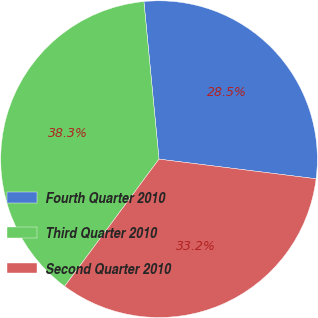Convert chart to OTSL. <chart><loc_0><loc_0><loc_500><loc_500><pie_chart><fcel>Fourth Quarter 2010<fcel>Third Quarter 2010<fcel>Second Quarter 2010<nl><fcel>28.5%<fcel>38.32%<fcel>33.18%<nl></chart> 